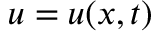<formula> <loc_0><loc_0><loc_500><loc_500>u = u ( x , t )</formula> 